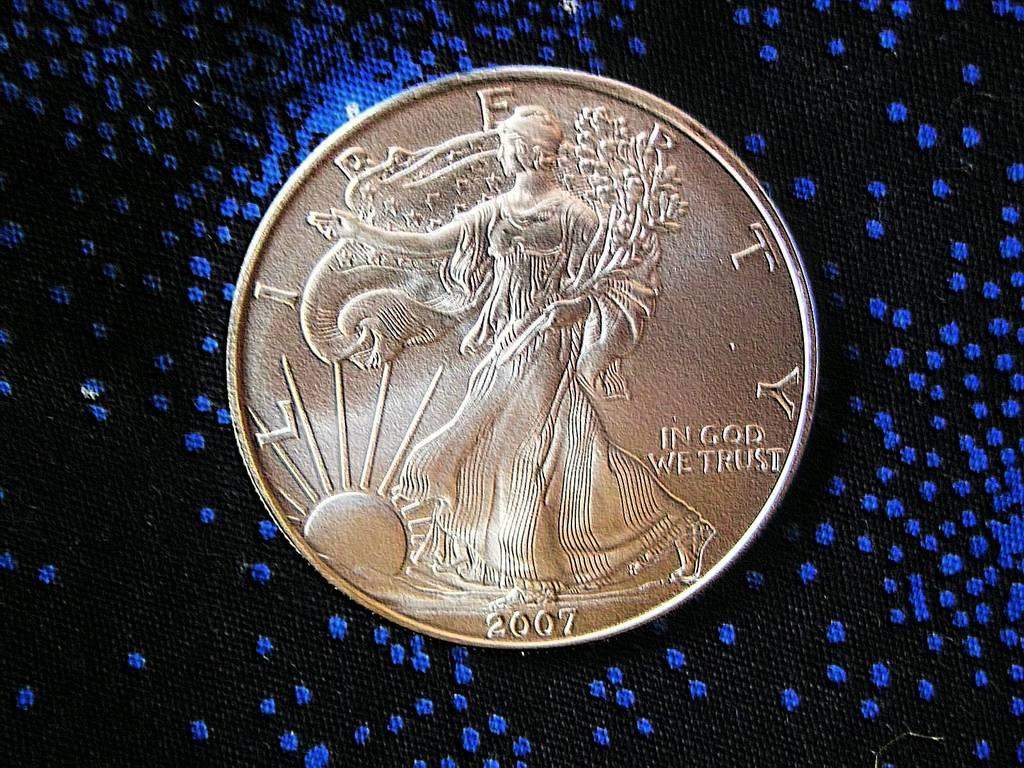<image>
Present a compact description of the photo's key features. The face of a 2007 Liberty coin with "In God We Trust" on the right side. 